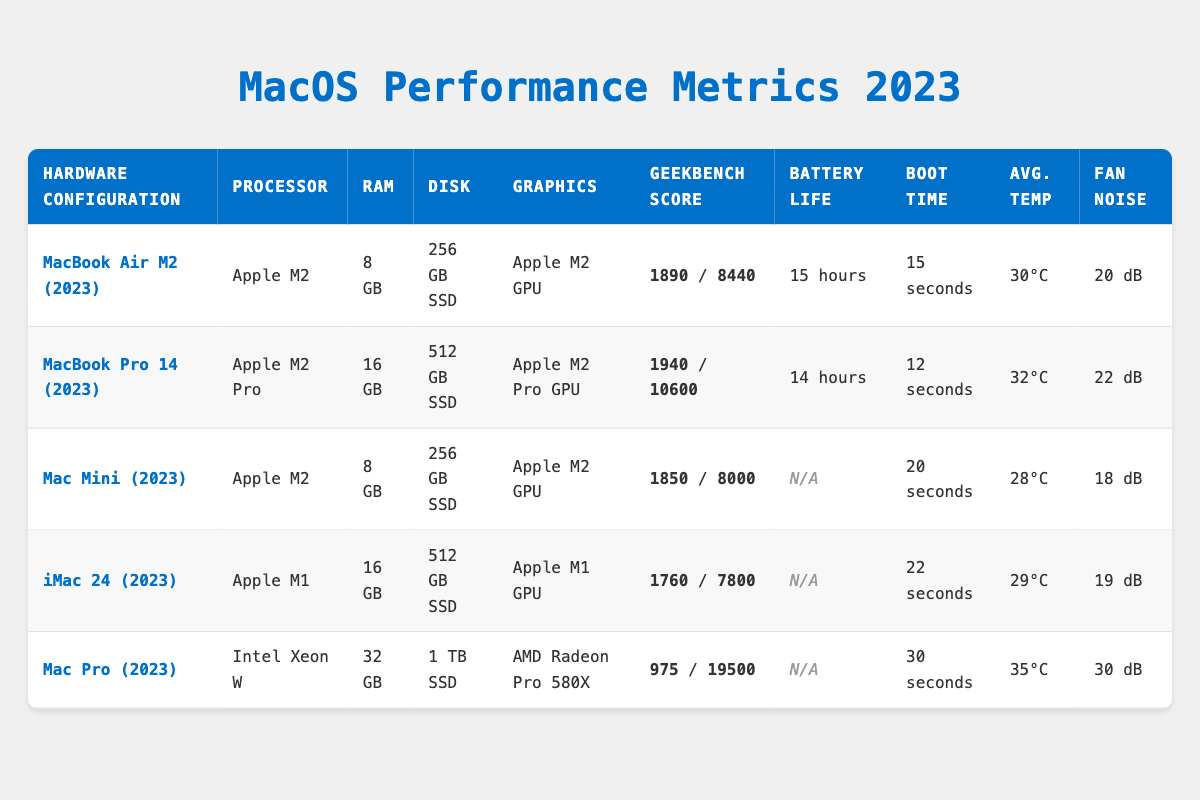What is the maximum battery life among the listed configurations? By reviewing the "Battery Life" column in the table, I find that the MacBook Air M2 (2023) has the longest battery life at 15 hours. Other configurations have shorter battery lives or are not applicable (N/A).
Answer: 15 hours Which configuration has the highest Geekbench multi-core score? In the "Geekbench Score" column, the Mac Pro (2023) has a multi-core score of 19500, which is the highest among all listed configurations.
Answer: 19500 Is the average temperature of MacBook Pro 14 (2023) higher than that of Mac Mini (2023)? The average temperature for MacBook Pro 14 (2023) is 32°C, and for Mac Mini (2023) it is 28°C. Since 32°C is greater than 28°C, the MacBook Pro's average temperature is indeed higher.
Answer: Yes What is the total RAM for all configurations combined? I will sum up the RAM across all configurations: 8 GB (MacBook Air) + 16 GB (MacBook Pro) + 8 GB (Mac Mini) + 16 GB (iMac) + 32 GB (Mac Pro) = 80 GB total RAM.
Answer: 80 GB How much longer does the MacBook Pro (2023) take to boot compared to the iMac 24 (2023)? The boot time for MacBook Pro (2023) is 12 seconds and for iMac 24 (2023) is 22 seconds. The difference is 22 seconds - 12 seconds = 10 seconds longer for iMac 24.
Answer: 10 seconds Which configuration has the lowest fan noise, and what is that noise level? By scanning the "Fan Noise" column, the Mac Mini (2023) has the lowest fan noise level at 18 dB compared to the others.
Answer: 18 dB Are there any configurations with no reported battery life? The Mac Mini (2023), iMac 24 (2023), and Mac Pro (2023) have "N/A" for battery life. Therefore, there are configurations without a reported battery life.
Answer: Yes What is the average Geekbench single-core score for all configurations? I will add the single-core scores: 1890 (MacBook Air) + 1940 (MacBook Pro) + 1850 (Mac Mini) + 1760 (iMac) + 975 (Mac Pro) = 8595. Dividing this by the number of configurations (5) gives me an average of 1718.
Answer: 1718 